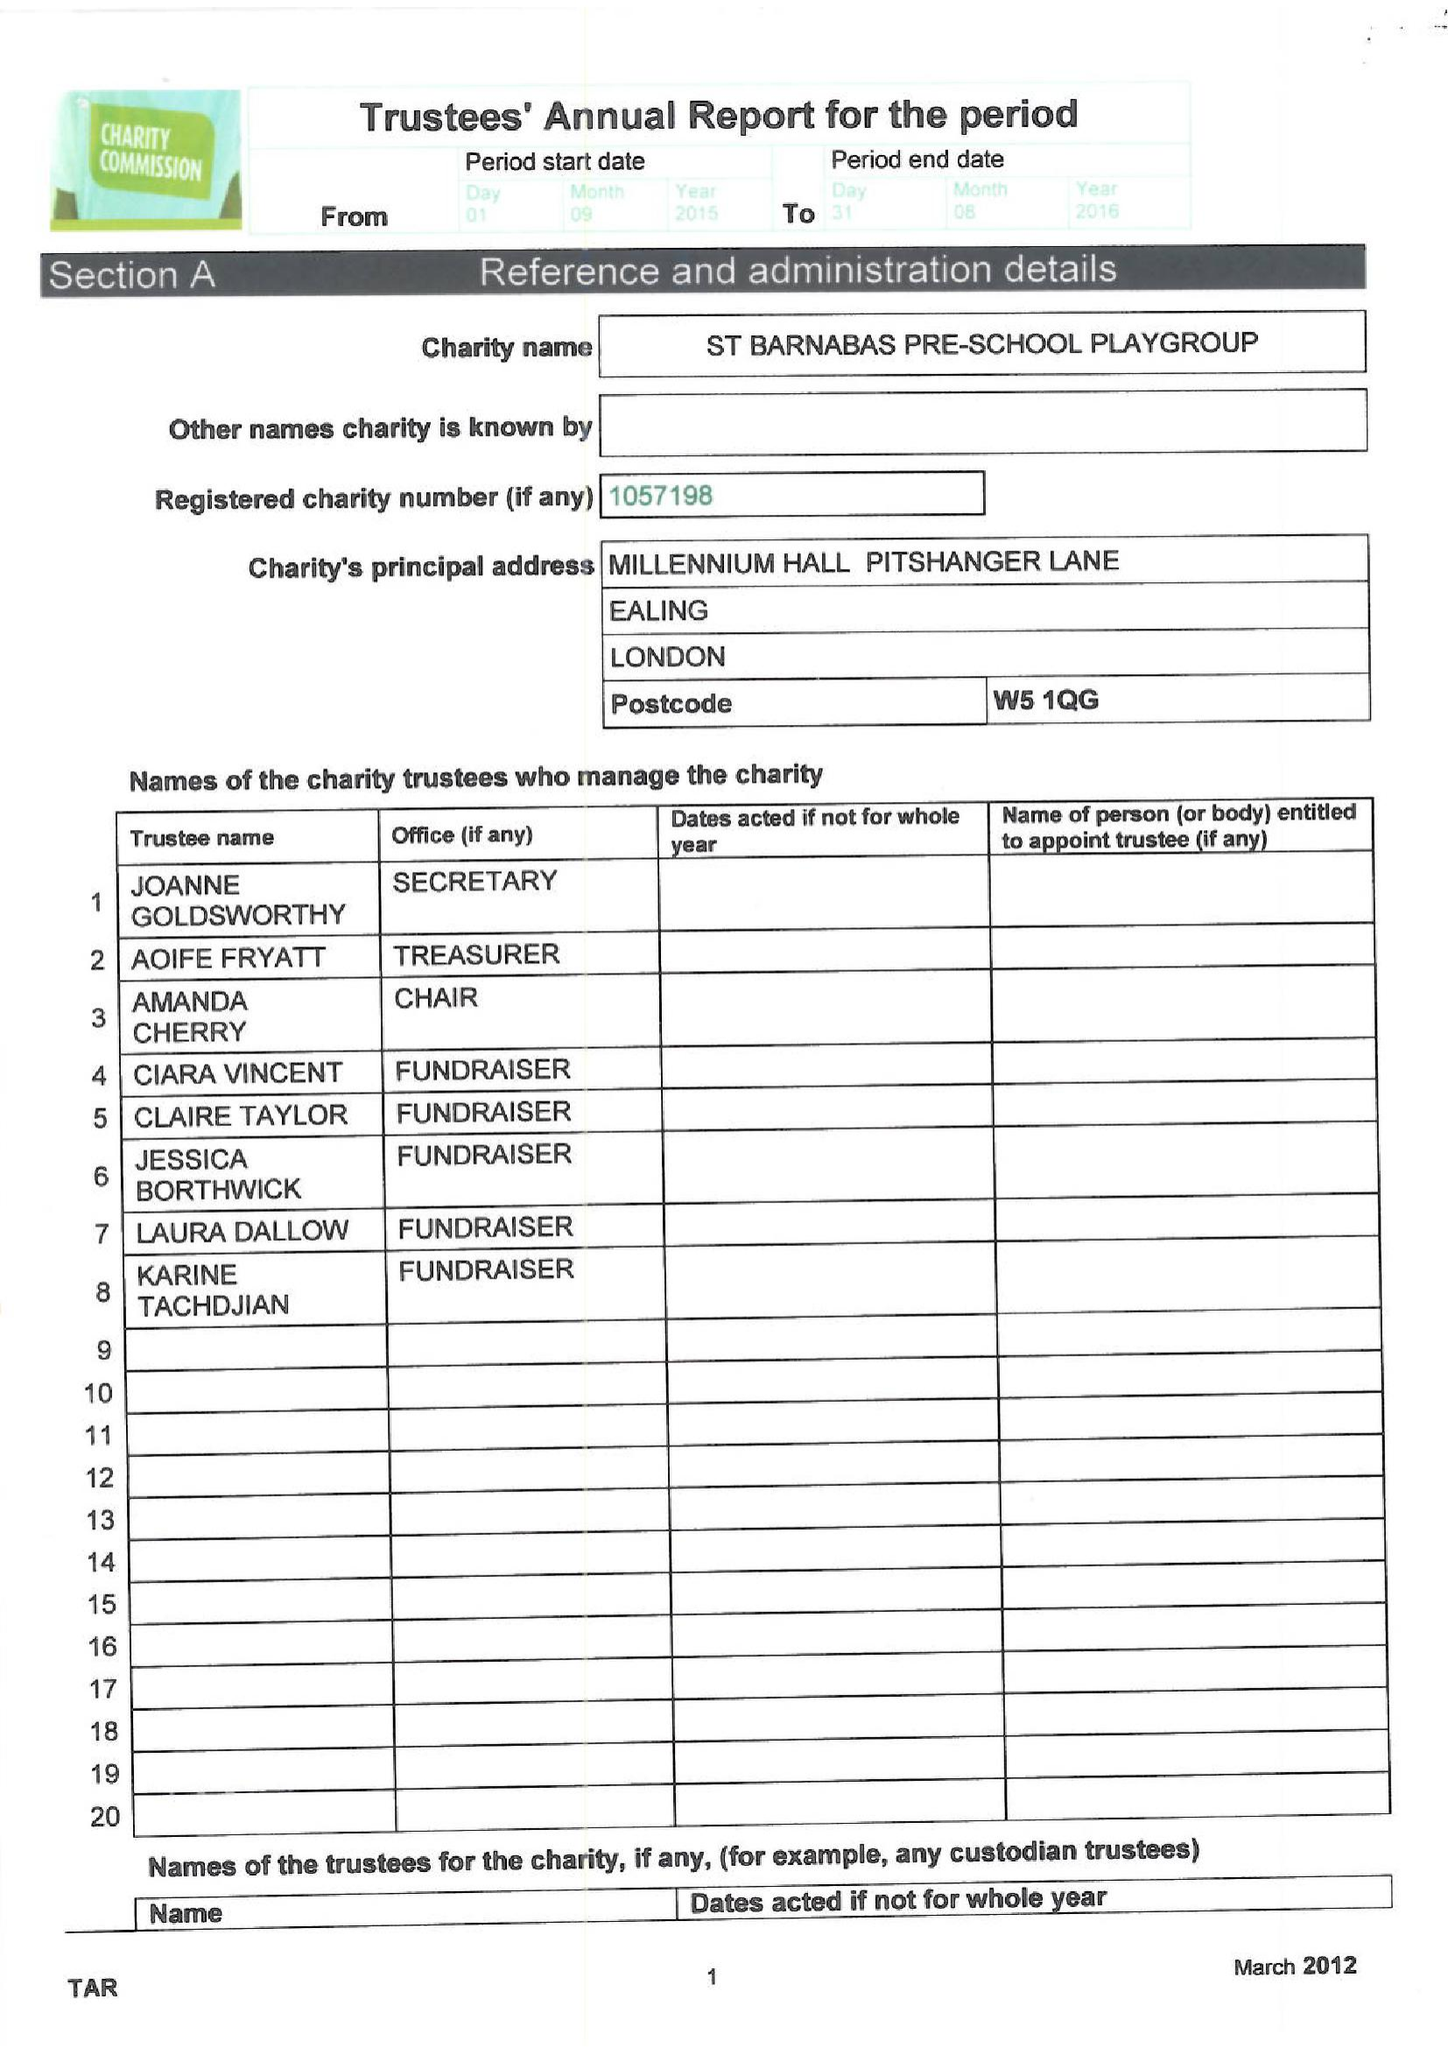What is the value for the address__postcode?
Answer the question using a single word or phrase. W5 1QG 